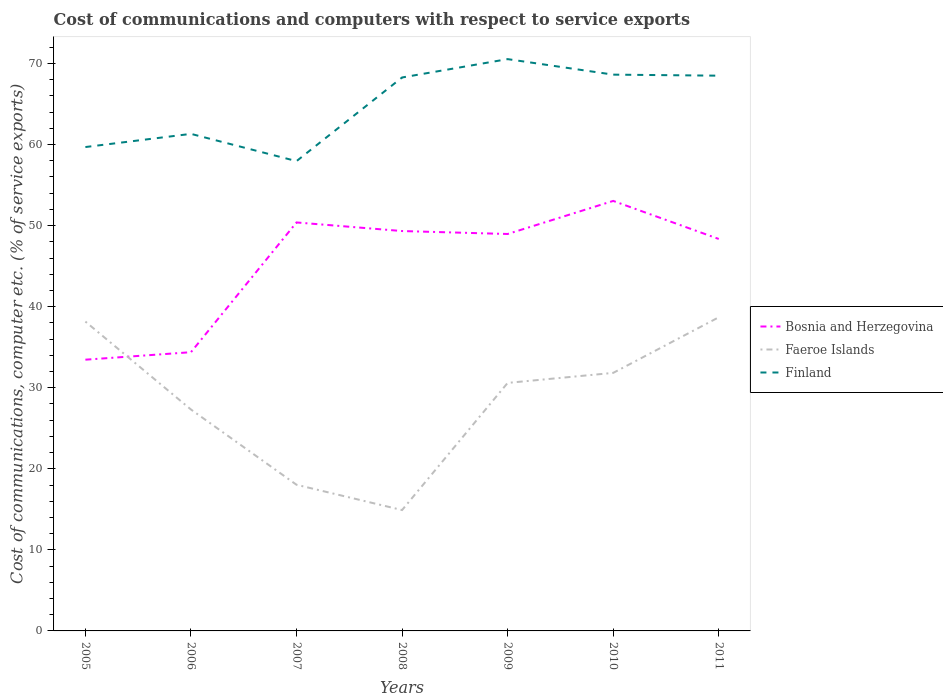Is the number of lines equal to the number of legend labels?
Your answer should be compact. Yes. Across all years, what is the maximum cost of communications and computers in Bosnia and Herzegovina?
Provide a succinct answer. 33.46. In which year was the cost of communications and computers in Finland maximum?
Provide a succinct answer. 2007. What is the total cost of communications and computers in Finland in the graph?
Give a very brief answer. -2.26. What is the difference between the highest and the second highest cost of communications and computers in Bosnia and Herzegovina?
Your answer should be very brief. 19.59. What is the difference between the highest and the lowest cost of communications and computers in Faeroe Islands?
Keep it short and to the point. 4. What is the difference between two consecutive major ticks on the Y-axis?
Make the answer very short. 10. Does the graph contain any zero values?
Make the answer very short. No. Does the graph contain grids?
Give a very brief answer. No. Where does the legend appear in the graph?
Provide a succinct answer. Center right. What is the title of the graph?
Your response must be concise. Cost of communications and computers with respect to service exports. Does "Central African Republic" appear as one of the legend labels in the graph?
Keep it short and to the point. No. What is the label or title of the Y-axis?
Offer a terse response. Cost of communications, computer etc. (% of service exports). What is the Cost of communications, computer etc. (% of service exports) in Bosnia and Herzegovina in 2005?
Keep it short and to the point. 33.46. What is the Cost of communications, computer etc. (% of service exports) in Faeroe Islands in 2005?
Offer a very short reply. 38.16. What is the Cost of communications, computer etc. (% of service exports) of Finland in 2005?
Offer a terse response. 59.69. What is the Cost of communications, computer etc. (% of service exports) in Bosnia and Herzegovina in 2006?
Keep it short and to the point. 34.38. What is the Cost of communications, computer etc. (% of service exports) of Faeroe Islands in 2006?
Give a very brief answer. 27.32. What is the Cost of communications, computer etc. (% of service exports) in Finland in 2006?
Offer a terse response. 61.32. What is the Cost of communications, computer etc. (% of service exports) of Bosnia and Herzegovina in 2007?
Offer a very short reply. 50.39. What is the Cost of communications, computer etc. (% of service exports) of Faeroe Islands in 2007?
Your answer should be compact. 18.03. What is the Cost of communications, computer etc. (% of service exports) of Finland in 2007?
Offer a terse response. 57.95. What is the Cost of communications, computer etc. (% of service exports) in Bosnia and Herzegovina in 2008?
Provide a short and direct response. 49.33. What is the Cost of communications, computer etc. (% of service exports) in Faeroe Islands in 2008?
Your response must be concise. 14.91. What is the Cost of communications, computer etc. (% of service exports) of Finland in 2008?
Make the answer very short. 68.27. What is the Cost of communications, computer etc. (% of service exports) in Bosnia and Herzegovina in 2009?
Give a very brief answer. 48.97. What is the Cost of communications, computer etc. (% of service exports) of Faeroe Islands in 2009?
Keep it short and to the point. 30.6. What is the Cost of communications, computer etc. (% of service exports) of Finland in 2009?
Ensure brevity in your answer.  70.54. What is the Cost of communications, computer etc. (% of service exports) in Bosnia and Herzegovina in 2010?
Give a very brief answer. 53.05. What is the Cost of communications, computer etc. (% of service exports) in Faeroe Islands in 2010?
Offer a very short reply. 31.83. What is the Cost of communications, computer etc. (% of service exports) of Finland in 2010?
Ensure brevity in your answer.  68.62. What is the Cost of communications, computer etc. (% of service exports) in Bosnia and Herzegovina in 2011?
Offer a very short reply. 48.35. What is the Cost of communications, computer etc. (% of service exports) of Faeroe Islands in 2011?
Provide a succinct answer. 38.69. What is the Cost of communications, computer etc. (% of service exports) in Finland in 2011?
Offer a very short reply. 68.5. Across all years, what is the maximum Cost of communications, computer etc. (% of service exports) of Bosnia and Herzegovina?
Offer a terse response. 53.05. Across all years, what is the maximum Cost of communications, computer etc. (% of service exports) in Faeroe Islands?
Provide a succinct answer. 38.69. Across all years, what is the maximum Cost of communications, computer etc. (% of service exports) of Finland?
Keep it short and to the point. 70.54. Across all years, what is the minimum Cost of communications, computer etc. (% of service exports) in Bosnia and Herzegovina?
Your answer should be very brief. 33.46. Across all years, what is the minimum Cost of communications, computer etc. (% of service exports) of Faeroe Islands?
Make the answer very short. 14.91. Across all years, what is the minimum Cost of communications, computer etc. (% of service exports) in Finland?
Your response must be concise. 57.95. What is the total Cost of communications, computer etc. (% of service exports) of Bosnia and Herzegovina in the graph?
Your response must be concise. 317.93. What is the total Cost of communications, computer etc. (% of service exports) of Faeroe Islands in the graph?
Provide a succinct answer. 199.54. What is the total Cost of communications, computer etc. (% of service exports) of Finland in the graph?
Provide a short and direct response. 454.9. What is the difference between the Cost of communications, computer etc. (% of service exports) of Bosnia and Herzegovina in 2005 and that in 2006?
Provide a succinct answer. -0.92. What is the difference between the Cost of communications, computer etc. (% of service exports) in Faeroe Islands in 2005 and that in 2006?
Your answer should be very brief. 10.85. What is the difference between the Cost of communications, computer etc. (% of service exports) in Finland in 2005 and that in 2006?
Make the answer very short. -1.63. What is the difference between the Cost of communications, computer etc. (% of service exports) of Bosnia and Herzegovina in 2005 and that in 2007?
Your answer should be very brief. -16.93. What is the difference between the Cost of communications, computer etc. (% of service exports) in Faeroe Islands in 2005 and that in 2007?
Ensure brevity in your answer.  20.13. What is the difference between the Cost of communications, computer etc. (% of service exports) of Finland in 2005 and that in 2007?
Ensure brevity in your answer.  1.74. What is the difference between the Cost of communications, computer etc. (% of service exports) in Bosnia and Herzegovina in 2005 and that in 2008?
Your answer should be very brief. -15.87. What is the difference between the Cost of communications, computer etc. (% of service exports) of Faeroe Islands in 2005 and that in 2008?
Your answer should be compact. 23.25. What is the difference between the Cost of communications, computer etc. (% of service exports) in Finland in 2005 and that in 2008?
Your answer should be compact. -8.58. What is the difference between the Cost of communications, computer etc. (% of service exports) of Bosnia and Herzegovina in 2005 and that in 2009?
Give a very brief answer. -15.51. What is the difference between the Cost of communications, computer etc. (% of service exports) in Faeroe Islands in 2005 and that in 2009?
Offer a terse response. 7.56. What is the difference between the Cost of communications, computer etc. (% of service exports) of Finland in 2005 and that in 2009?
Provide a short and direct response. -10.85. What is the difference between the Cost of communications, computer etc. (% of service exports) of Bosnia and Herzegovina in 2005 and that in 2010?
Offer a terse response. -19.59. What is the difference between the Cost of communications, computer etc. (% of service exports) in Faeroe Islands in 2005 and that in 2010?
Provide a short and direct response. 6.33. What is the difference between the Cost of communications, computer etc. (% of service exports) of Finland in 2005 and that in 2010?
Ensure brevity in your answer.  -8.93. What is the difference between the Cost of communications, computer etc. (% of service exports) of Bosnia and Herzegovina in 2005 and that in 2011?
Offer a very short reply. -14.89. What is the difference between the Cost of communications, computer etc. (% of service exports) of Faeroe Islands in 2005 and that in 2011?
Your answer should be compact. -0.53. What is the difference between the Cost of communications, computer etc. (% of service exports) in Finland in 2005 and that in 2011?
Provide a short and direct response. -8.8. What is the difference between the Cost of communications, computer etc. (% of service exports) of Bosnia and Herzegovina in 2006 and that in 2007?
Give a very brief answer. -16.01. What is the difference between the Cost of communications, computer etc. (% of service exports) in Faeroe Islands in 2006 and that in 2007?
Offer a terse response. 9.28. What is the difference between the Cost of communications, computer etc. (% of service exports) of Finland in 2006 and that in 2007?
Your answer should be compact. 3.36. What is the difference between the Cost of communications, computer etc. (% of service exports) of Bosnia and Herzegovina in 2006 and that in 2008?
Your answer should be very brief. -14.95. What is the difference between the Cost of communications, computer etc. (% of service exports) in Faeroe Islands in 2006 and that in 2008?
Offer a terse response. 12.41. What is the difference between the Cost of communications, computer etc. (% of service exports) of Finland in 2006 and that in 2008?
Ensure brevity in your answer.  -6.96. What is the difference between the Cost of communications, computer etc. (% of service exports) of Bosnia and Herzegovina in 2006 and that in 2009?
Offer a terse response. -14.58. What is the difference between the Cost of communications, computer etc. (% of service exports) of Faeroe Islands in 2006 and that in 2009?
Your answer should be very brief. -3.28. What is the difference between the Cost of communications, computer etc. (% of service exports) in Finland in 2006 and that in 2009?
Give a very brief answer. -9.22. What is the difference between the Cost of communications, computer etc. (% of service exports) in Bosnia and Herzegovina in 2006 and that in 2010?
Give a very brief answer. -18.66. What is the difference between the Cost of communications, computer etc. (% of service exports) of Faeroe Islands in 2006 and that in 2010?
Your response must be concise. -4.52. What is the difference between the Cost of communications, computer etc. (% of service exports) in Finland in 2006 and that in 2010?
Offer a terse response. -7.31. What is the difference between the Cost of communications, computer etc. (% of service exports) in Bosnia and Herzegovina in 2006 and that in 2011?
Your answer should be very brief. -13.97. What is the difference between the Cost of communications, computer etc. (% of service exports) of Faeroe Islands in 2006 and that in 2011?
Provide a succinct answer. -11.38. What is the difference between the Cost of communications, computer etc. (% of service exports) in Finland in 2006 and that in 2011?
Make the answer very short. -7.18. What is the difference between the Cost of communications, computer etc. (% of service exports) in Bosnia and Herzegovina in 2007 and that in 2008?
Give a very brief answer. 1.06. What is the difference between the Cost of communications, computer etc. (% of service exports) of Faeroe Islands in 2007 and that in 2008?
Ensure brevity in your answer.  3.12. What is the difference between the Cost of communications, computer etc. (% of service exports) in Finland in 2007 and that in 2008?
Offer a very short reply. -10.32. What is the difference between the Cost of communications, computer etc. (% of service exports) of Bosnia and Herzegovina in 2007 and that in 2009?
Your answer should be compact. 1.42. What is the difference between the Cost of communications, computer etc. (% of service exports) of Faeroe Islands in 2007 and that in 2009?
Make the answer very short. -12.57. What is the difference between the Cost of communications, computer etc. (% of service exports) of Finland in 2007 and that in 2009?
Your answer should be compact. -12.58. What is the difference between the Cost of communications, computer etc. (% of service exports) of Bosnia and Herzegovina in 2007 and that in 2010?
Make the answer very short. -2.66. What is the difference between the Cost of communications, computer etc. (% of service exports) in Faeroe Islands in 2007 and that in 2010?
Ensure brevity in your answer.  -13.8. What is the difference between the Cost of communications, computer etc. (% of service exports) in Finland in 2007 and that in 2010?
Your answer should be very brief. -10.67. What is the difference between the Cost of communications, computer etc. (% of service exports) of Bosnia and Herzegovina in 2007 and that in 2011?
Offer a very short reply. 2.04. What is the difference between the Cost of communications, computer etc. (% of service exports) of Faeroe Islands in 2007 and that in 2011?
Keep it short and to the point. -20.66. What is the difference between the Cost of communications, computer etc. (% of service exports) of Finland in 2007 and that in 2011?
Provide a short and direct response. -10.54. What is the difference between the Cost of communications, computer etc. (% of service exports) in Bosnia and Herzegovina in 2008 and that in 2009?
Ensure brevity in your answer.  0.36. What is the difference between the Cost of communications, computer etc. (% of service exports) in Faeroe Islands in 2008 and that in 2009?
Offer a terse response. -15.69. What is the difference between the Cost of communications, computer etc. (% of service exports) of Finland in 2008 and that in 2009?
Offer a terse response. -2.26. What is the difference between the Cost of communications, computer etc. (% of service exports) of Bosnia and Herzegovina in 2008 and that in 2010?
Provide a succinct answer. -3.72. What is the difference between the Cost of communications, computer etc. (% of service exports) in Faeroe Islands in 2008 and that in 2010?
Your answer should be compact. -16.92. What is the difference between the Cost of communications, computer etc. (% of service exports) in Finland in 2008 and that in 2010?
Give a very brief answer. -0.35. What is the difference between the Cost of communications, computer etc. (% of service exports) of Bosnia and Herzegovina in 2008 and that in 2011?
Your answer should be compact. 0.98. What is the difference between the Cost of communications, computer etc. (% of service exports) of Faeroe Islands in 2008 and that in 2011?
Your response must be concise. -23.78. What is the difference between the Cost of communications, computer etc. (% of service exports) of Finland in 2008 and that in 2011?
Give a very brief answer. -0.22. What is the difference between the Cost of communications, computer etc. (% of service exports) of Bosnia and Herzegovina in 2009 and that in 2010?
Provide a short and direct response. -4.08. What is the difference between the Cost of communications, computer etc. (% of service exports) of Faeroe Islands in 2009 and that in 2010?
Keep it short and to the point. -1.24. What is the difference between the Cost of communications, computer etc. (% of service exports) in Finland in 2009 and that in 2010?
Keep it short and to the point. 1.91. What is the difference between the Cost of communications, computer etc. (% of service exports) of Bosnia and Herzegovina in 2009 and that in 2011?
Offer a very short reply. 0.61. What is the difference between the Cost of communications, computer etc. (% of service exports) of Faeroe Islands in 2009 and that in 2011?
Your response must be concise. -8.1. What is the difference between the Cost of communications, computer etc. (% of service exports) in Finland in 2009 and that in 2011?
Your answer should be compact. 2.04. What is the difference between the Cost of communications, computer etc. (% of service exports) in Bosnia and Herzegovina in 2010 and that in 2011?
Keep it short and to the point. 4.69. What is the difference between the Cost of communications, computer etc. (% of service exports) in Faeroe Islands in 2010 and that in 2011?
Make the answer very short. -6.86. What is the difference between the Cost of communications, computer etc. (% of service exports) of Finland in 2010 and that in 2011?
Offer a very short reply. 0.13. What is the difference between the Cost of communications, computer etc. (% of service exports) of Bosnia and Herzegovina in 2005 and the Cost of communications, computer etc. (% of service exports) of Faeroe Islands in 2006?
Keep it short and to the point. 6.14. What is the difference between the Cost of communications, computer etc. (% of service exports) of Bosnia and Herzegovina in 2005 and the Cost of communications, computer etc. (% of service exports) of Finland in 2006?
Provide a succinct answer. -27.86. What is the difference between the Cost of communications, computer etc. (% of service exports) of Faeroe Islands in 2005 and the Cost of communications, computer etc. (% of service exports) of Finland in 2006?
Provide a succinct answer. -23.16. What is the difference between the Cost of communications, computer etc. (% of service exports) of Bosnia and Herzegovina in 2005 and the Cost of communications, computer etc. (% of service exports) of Faeroe Islands in 2007?
Your answer should be compact. 15.43. What is the difference between the Cost of communications, computer etc. (% of service exports) of Bosnia and Herzegovina in 2005 and the Cost of communications, computer etc. (% of service exports) of Finland in 2007?
Your answer should be very brief. -24.5. What is the difference between the Cost of communications, computer etc. (% of service exports) in Faeroe Islands in 2005 and the Cost of communications, computer etc. (% of service exports) in Finland in 2007?
Offer a very short reply. -19.79. What is the difference between the Cost of communications, computer etc. (% of service exports) in Bosnia and Herzegovina in 2005 and the Cost of communications, computer etc. (% of service exports) in Faeroe Islands in 2008?
Keep it short and to the point. 18.55. What is the difference between the Cost of communications, computer etc. (% of service exports) of Bosnia and Herzegovina in 2005 and the Cost of communications, computer etc. (% of service exports) of Finland in 2008?
Provide a succinct answer. -34.81. What is the difference between the Cost of communications, computer etc. (% of service exports) of Faeroe Islands in 2005 and the Cost of communications, computer etc. (% of service exports) of Finland in 2008?
Make the answer very short. -30.11. What is the difference between the Cost of communications, computer etc. (% of service exports) in Bosnia and Herzegovina in 2005 and the Cost of communications, computer etc. (% of service exports) in Faeroe Islands in 2009?
Ensure brevity in your answer.  2.86. What is the difference between the Cost of communications, computer etc. (% of service exports) of Bosnia and Herzegovina in 2005 and the Cost of communications, computer etc. (% of service exports) of Finland in 2009?
Give a very brief answer. -37.08. What is the difference between the Cost of communications, computer etc. (% of service exports) of Faeroe Islands in 2005 and the Cost of communications, computer etc. (% of service exports) of Finland in 2009?
Ensure brevity in your answer.  -32.38. What is the difference between the Cost of communications, computer etc. (% of service exports) of Bosnia and Herzegovina in 2005 and the Cost of communications, computer etc. (% of service exports) of Faeroe Islands in 2010?
Provide a succinct answer. 1.63. What is the difference between the Cost of communications, computer etc. (% of service exports) in Bosnia and Herzegovina in 2005 and the Cost of communications, computer etc. (% of service exports) in Finland in 2010?
Provide a short and direct response. -35.16. What is the difference between the Cost of communications, computer etc. (% of service exports) of Faeroe Islands in 2005 and the Cost of communications, computer etc. (% of service exports) of Finland in 2010?
Your answer should be very brief. -30.46. What is the difference between the Cost of communications, computer etc. (% of service exports) of Bosnia and Herzegovina in 2005 and the Cost of communications, computer etc. (% of service exports) of Faeroe Islands in 2011?
Your answer should be very brief. -5.23. What is the difference between the Cost of communications, computer etc. (% of service exports) in Bosnia and Herzegovina in 2005 and the Cost of communications, computer etc. (% of service exports) in Finland in 2011?
Your answer should be very brief. -35.04. What is the difference between the Cost of communications, computer etc. (% of service exports) in Faeroe Islands in 2005 and the Cost of communications, computer etc. (% of service exports) in Finland in 2011?
Provide a succinct answer. -30.33. What is the difference between the Cost of communications, computer etc. (% of service exports) in Bosnia and Herzegovina in 2006 and the Cost of communications, computer etc. (% of service exports) in Faeroe Islands in 2007?
Your answer should be compact. 16.35. What is the difference between the Cost of communications, computer etc. (% of service exports) in Bosnia and Herzegovina in 2006 and the Cost of communications, computer etc. (% of service exports) in Finland in 2007?
Your response must be concise. -23.57. What is the difference between the Cost of communications, computer etc. (% of service exports) of Faeroe Islands in 2006 and the Cost of communications, computer etc. (% of service exports) of Finland in 2007?
Provide a short and direct response. -30.64. What is the difference between the Cost of communications, computer etc. (% of service exports) of Bosnia and Herzegovina in 2006 and the Cost of communications, computer etc. (% of service exports) of Faeroe Islands in 2008?
Offer a terse response. 19.47. What is the difference between the Cost of communications, computer etc. (% of service exports) of Bosnia and Herzegovina in 2006 and the Cost of communications, computer etc. (% of service exports) of Finland in 2008?
Provide a short and direct response. -33.89. What is the difference between the Cost of communications, computer etc. (% of service exports) of Faeroe Islands in 2006 and the Cost of communications, computer etc. (% of service exports) of Finland in 2008?
Offer a terse response. -40.96. What is the difference between the Cost of communications, computer etc. (% of service exports) of Bosnia and Herzegovina in 2006 and the Cost of communications, computer etc. (% of service exports) of Faeroe Islands in 2009?
Offer a terse response. 3.79. What is the difference between the Cost of communications, computer etc. (% of service exports) of Bosnia and Herzegovina in 2006 and the Cost of communications, computer etc. (% of service exports) of Finland in 2009?
Provide a short and direct response. -36.15. What is the difference between the Cost of communications, computer etc. (% of service exports) in Faeroe Islands in 2006 and the Cost of communications, computer etc. (% of service exports) in Finland in 2009?
Give a very brief answer. -43.22. What is the difference between the Cost of communications, computer etc. (% of service exports) of Bosnia and Herzegovina in 2006 and the Cost of communications, computer etc. (% of service exports) of Faeroe Islands in 2010?
Keep it short and to the point. 2.55. What is the difference between the Cost of communications, computer etc. (% of service exports) of Bosnia and Herzegovina in 2006 and the Cost of communications, computer etc. (% of service exports) of Finland in 2010?
Your answer should be compact. -34.24. What is the difference between the Cost of communications, computer etc. (% of service exports) in Faeroe Islands in 2006 and the Cost of communications, computer etc. (% of service exports) in Finland in 2010?
Provide a succinct answer. -41.31. What is the difference between the Cost of communications, computer etc. (% of service exports) of Bosnia and Herzegovina in 2006 and the Cost of communications, computer etc. (% of service exports) of Faeroe Islands in 2011?
Offer a very short reply. -4.31. What is the difference between the Cost of communications, computer etc. (% of service exports) of Bosnia and Herzegovina in 2006 and the Cost of communications, computer etc. (% of service exports) of Finland in 2011?
Your response must be concise. -34.11. What is the difference between the Cost of communications, computer etc. (% of service exports) of Faeroe Islands in 2006 and the Cost of communications, computer etc. (% of service exports) of Finland in 2011?
Keep it short and to the point. -41.18. What is the difference between the Cost of communications, computer etc. (% of service exports) in Bosnia and Herzegovina in 2007 and the Cost of communications, computer etc. (% of service exports) in Faeroe Islands in 2008?
Give a very brief answer. 35.48. What is the difference between the Cost of communications, computer etc. (% of service exports) in Bosnia and Herzegovina in 2007 and the Cost of communications, computer etc. (% of service exports) in Finland in 2008?
Ensure brevity in your answer.  -17.88. What is the difference between the Cost of communications, computer etc. (% of service exports) of Faeroe Islands in 2007 and the Cost of communications, computer etc. (% of service exports) of Finland in 2008?
Provide a succinct answer. -50.24. What is the difference between the Cost of communications, computer etc. (% of service exports) in Bosnia and Herzegovina in 2007 and the Cost of communications, computer etc. (% of service exports) in Faeroe Islands in 2009?
Provide a short and direct response. 19.79. What is the difference between the Cost of communications, computer etc. (% of service exports) of Bosnia and Herzegovina in 2007 and the Cost of communications, computer etc. (% of service exports) of Finland in 2009?
Offer a terse response. -20.15. What is the difference between the Cost of communications, computer etc. (% of service exports) in Faeroe Islands in 2007 and the Cost of communications, computer etc. (% of service exports) in Finland in 2009?
Offer a terse response. -52.51. What is the difference between the Cost of communications, computer etc. (% of service exports) in Bosnia and Herzegovina in 2007 and the Cost of communications, computer etc. (% of service exports) in Faeroe Islands in 2010?
Give a very brief answer. 18.56. What is the difference between the Cost of communications, computer etc. (% of service exports) of Bosnia and Herzegovina in 2007 and the Cost of communications, computer etc. (% of service exports) of Finland in 2010?
Your answer should be very brief. -18.23. What is the difference between the Cost of communications, computer etc. (% of service exports) in Faeroe Islands in 2007 and the Cost of communications, computer etc. (% of service exports) in Finland in 2010?
Make the answer very short. -50.59. What is the difference between the Cost of communications, computer etc. (% of service exports) in Bosnia and Herzegovina in 2007 and the Cost of communications, computer etc. (% of service exports) in Faeroe Islands in 2011?
Offer a very short reply. 11.7. What is the difference between the Cost of communications, computer etc. (% of service exports) of Bosnia and Herzegovina in 2007 and the Cost of communications, computer etc. (% of service exports) of Finland in 2011?
Make the answer very short. -18.11. What is the difference between the Cost of communications, computer etc. (% of service exports) in Faeroe Islands in 2007 and the Cost of communications, computer etc. (% of service exports) in Finland in 2011?
Your response must be concise. -50.47. What is the difference between the Cost of communications, computer etc. (% of service exports) in Bosnia and Herzegovina in 2008 and the Cost of communications, computer etc. (% of service exports) in Faeroe Islands in 2009?
Provide a succinct answer. 18.73. What is the difference between the Cost of communications, computer etc. (% of service exports) of Bosnia and Herzegovina in 2008 and the Cost of communications, computer etc. (% of service exports) of Finland in 2009?
Your answer should be very brief. -21.21. What is the difference between the Cost of communications, computer etc. (% of service exports) in Faeroe Islands in 2008 and the Cost of communications, computer etc. (% of service exports) in Finland in 2009?
Provide a succinct answer. -55.63. What is the difference between the Cost of communications, computer etc. (% of service exports) in Bosnia and Herzegovina in 2008 and the Cost of communications, computer etc. (% of service exports) in Faeroe Islands in 2010?
Make the answer very short. 17.5. What is the difference between the Cost of communications, computer etc. (% of service exports) in Bosnia and Herzegovina in 2008 and the Cost of communications, computer etc. (% of service exports) in Finland in 2010?
Ensure brevity in your answer.  -19.29. What is the difference between the Cost of communications, computer etc. (% of service exports) in Faeroe Islands in 2008 and the Cost of communications, computer etc. (% of service exports) in Finland in 2010?
Make the answer very short. -53.71. What is the difference between the Cost of communications, computer etc. (% of service exports) in Bosnia and Herzegovina in 2008 and the Cost of communications, computer etc. (% of service exports) in Faeroe Islands in 2011?
Your response must be concise. 10.64. What is the difference between the Cost of communications, computer etc. (% of service exports) of Bosnia and Herzegovina in 2008 and the Cost of communications, computer etc. (% of service exports) of Finland in 2011?
Offer a very short reply. -19.17. What is the difference between the Cost of communications, computer etc. (% of service exports) in Faeroe Islands in 2008 and the Cost of communications, computer etc. (% of service exports) in Finland in 2011?
Offer a very short reply. -53.59. What is the difference between the Cost of communications, computer etc. (% of service exports) of Bosnia and Herzegovina in 2009 and the Cost of communications, computer etc. (% of service exports) of Faeroe Islands in 2010?
Offer a very short reply. 17.13. What is the difference between the Cost of communications, computer etc. (% of service exports) in Bosnia and Herzegovina in 2009 and the Cost of communications, computer etc. (% of service exports) in Finland in 2010?
Provide a succinct answer. -19.66. What is the difference between the Cost of communications, computer etc. (% of service exports) in Faeroe Islands in 2009 and the Cost of communications, computer etc. (% of service exports) in Finland in 2010?
Keep it short and to the point. -38.03. What is the difference between the Cost of communications, computer etc. (% of service exports) of Bosnia and Herzegovina in 2009 and the Cost of communications, computer etc. (% of service exports) of Faeroe Islands in 2011?
Your answer should be very brief. 10.27. What is the difference between the Cost of communications, computer etc. (% of service exports) in Bosnia and Herzegovina in 2009 and the Cost of communications, computer etc. (% of service exports) in Finland in 2011?
Your answer should be compact. -19.53. What is the difference between the Cost of communications, computer etc. (% of service exports) of Faeroe Islands in 2009 and the Cost of communications, computer etc. (% of service exports) of Finland in 2011?
Ensure brevity in your answer.  -37.9. What is the difference between the Cost of communications, computer etc. (% of service exports) of Bosnia and Herzegovina in 2010 and the Cost of communications, computer etc. (% of service exports) of Faeroe Islands in 2011?
Provide a succinct answer. 14.35. What is the difference between the Cost of communications, computer etc. (% of service exports) of Bosnia and Herzegovina in 2010 and the Cost of communications, computer etc. (% of service exports) of Finland in 2011?
Provide a short and direct response. -15.45. What is the difference between the Cost of communications, computer etc. (% of service exports) of Faeroe Islands in 2010 and the Cost of communications, computer etc. (% of service exports) of Finland in 2011?
Give a very brief answer. -36.66. What is the average Cost of communications, computer etc. (% of service exports) in Bosnia and Herzegovina per year?
Ensure brevity in your answer.  45.42. What is the average Cost of communications, computer etc. (% of service exports) of Faeroe Islands per year?
Your response must be concise. 28.51. What is the average Cost of communications, computer etc. (% of service exports) of Finland per year?
Your answer should be very brief. 64.99. In the year 2005, what is the difference between the Cost of communications, computer etc. (% of service exports) in Bosnia and Herzegovina and Cost of communications, computer etc. (% of service exports) in Faeroe Islands?
Provide a short and direct response. -4.7. In the year 2005, what is the difference between the Cost of communications, computer etc. (% of service exports) of Bosnia and Herzegovina and Cost of communications, computer etc. (% of service exports) of Finland?
Your answer should be compact. -26.23. In the year 2005, what is the difference between the Cost of communications, computer etc. (% of service exports) of Faeroe Islands and Cost of communications, computer etc. (% of service exports) of Finland?
Give a very brief answer. -21.53. In the year 2006, what is the difference between the Cost of communications, computer etc. (% of service exports) of Bosnia and Herzegovina and Cost of communications, computer etc. (% of service exports) of Faeroe Islands?
Ensure brevity in your answer.  7.07. In the year 2006, what is the difference between the Cost of communications, computer etc. (% of service exports) in Bosnia and Herzegovina and Cost of communications, computer etc. (% of service exports) in Finland?
Give a very brief answer. -26.93. In the year 2006, what is the difference between the Cost of communications, computer etc. (% of service exports) in Faeroe Islands and Cost of communications, computer etc. (% of service exports) in Finland?
Ensure brevity in your answer.  -34. In the year 2007, what is the difference between the Cost of communications, computer etc. (% of service exports) in Bosnia and Herzegovina and Cost of communications, computer etc. (% of service exports) in Faeroe Islands?
Offer a very short reply. 32.36. In the year 2007, what is the difference between the Cost of communications, computer etc. (% of service exports) of Bosnia and Herzegovina and Cost of communications, computer etc. (% of service exports) of Finland?
Your answer should be compact. -7.56. In the year 2007, what is the difference between the Cost of communications, computer etc. (% of service exports) in Faeroe Islands and Cost of communications, computer etc. (% of service exports) in Finland?
Provide a succinct answer. -39.92. In the year 2008, what is the difference between the Cost of communications, computer etc. (% of service exports) in Bosnia and Herzegovina and Cost of communications, computer etc. (% of service exports) in Faeroe Islands?
Ensure brevity in your answer.  34.42. In the year 2008, what is the difference between the Cost of communications, computer etc. (% of service exports) in Bosnia and Herzegovina and Cost of communications, computer etc. (% of service exports) in Finland?
Your answer should be very brief. -18.94. In the year 2008, what is the difference between the Cost of communications, computer etc. (% of service exports) of Faeroe Islands and Cost of communications, computer etc. (% of service exports) of Finland?
Ensure brevity in your answer.  -53.36. In the year 2009, what is the difference between the Cost of communications, computer etc. (% of service exports) in Bosnia and Herzegovina and Cost of communications, computer etc. (% of service exports) in Faeroe Islands?
Give a very brief answer. 18.37. In the year 2009, what is the difference between the Cost of communications, computer etc. (% of service exports) in Bosnia and Herzegovina and Cost of communications, computer etc. (% of service exports) in Finland?
Offer a terse response. -21.57. In the year 2009, what is the difference between the Cost of communications, computer etc. (% of service exports) in Faeroe Islands and Cost of communications, computer etc. (% of service exports) in Finland?
Keep it short and to the point. -39.94. In the year 2010, what is the difference between the Cost of communications, computer etc. (% of service exports) in Bosnia and Herzegovina and Cost of communications, computer etc. (% of service exports) in Faeroe Islands?
Offer a very short reply. 21.21. In the year 2010, what is the difference between the Cost of communications, computer etc. (% of service exports) in Bosnia and Herzegovina and Cost of communications, computer etc. (% of service exports) in Finland?
Give a very brief answer. -15.58. In the year 2010, what is the difference between the Cost of communications, computer etc. (% of service exports) in Faeroe Islands and Cost of communications, computer etc. (% of service exports) in Finland?
Provide a short and direct response. -36.79. In the year 2011, what is the difference between the Cost of communications, computer etc. (% of service exports) of Bosnia and Herzegovina and Cost of communications, computer etc. (% of service exports) of Faeroe Islands?
Offer a terse response. 9.66. In the year 2011, what is the difference between the Cost of communications, computer etc. (% of service exports) of Bosnia and Herzegovina and Cost of communications, computer etc. (% of service exports) of Finland?
Give a very brief answer. -20.14. In the year 2011, what is the difference between the Cost of communications, computer etc. (% of service exports) of Faeroe Islands and Cost of communications, computer etc. (% of service exports) of Finland?
Provide a succinct answer. -29.8. What is the ratio of the Cost of communications, computer etc. (% of service exports) in Bosnia and Herzegovina in 2005 to that in 2006?
Your answer should be compact. 0.97. What is the ratio of the Cost of communications, computer etc. (% of service exports) in Faeroe Islands in 2005 to that in 2006?
Provide a short and direct response. 1.4. What is the ratio of the Cost of communications, computer etc. (% of service exports) in Finland in 2005 to that in 2006?
Offer a terse response. 0.97. What is the ratio of the Cost of communications, computer etc. (% of service exports) of Bosnia and Herzegovina in 2005 to that in 2007?
Your response must be concise. 0.66. What is the ratio of the Cost of communications, computer etc. (% of service exports) of Faeroe Islands in 2005 to that in 2007?
Offer a very short reply. 2.12. What is the ratio of the Cost of communications, computer etc. (% of service exports) in Finland in 2005 to that in 2007?
Offer a very short reply. 1.03. What is the ratio of the Cost of communications, computer etc. (% of service exports) in Bosnia and Herzegovina in 2005 to that in 2008?
Offer a terse response. 0.68. What is the ratio of the Cost of communications, computer etc. (% of service exports) of Faeroe Islands in 2005 to that in 2008?
Keep it short and to the point. 2.56. What is the ratio of the Cost of communications, computer etc. (% of service exports) of Finland in 2005 to that in 2008?
Your answer should be very brief. 0.87. What is the ratio of the Cost of communications, computer etc. (% of service exports) in Bosnia and Herzegovina in 2005 to that in 2009?
Provide a short and direct response. 0.68. What is the ratio of the Cost of communications, computer etc. (% of service exports) of Faeroe Islands in 2005 to that in 2009?
Your answer should be compact. 1.25. What is the ratio of the Cost of communications, computer etc. (% of service exports) of Finland in 2005 to that in 2009?
Provide a succinct answer. 0.85. What is the ratio of the Cost of communications, computer etc. (% of service exports) of Bosnia and Herzegovina in 2005 to that in 2010?
Provide a short and direct response. 0.63. What is the ratio of the Cost of communications, computer etc. (% of service exports) in Faeroe Islands in 2005 to that in 2010?
Provide a short and direct response. 1.2. What is the ratio of the Cost of communications, computer etc. (% of service exports) of Finland in 2005 to that in 2010?
Keep it short and to the point. 0.87. What is the ratio of the Cost of communications, computer etc. (% of service exports) of Bosnia and Herzegovina in 2005 to that in 2011?
Offer a terse response. 0.69. What is the ratio of the Cost of communications, computer etc. (% of service exports) in Faeroe Islands in 2005 to that in 2011?
Provide a short and direct response. 0.99. What is the ratio of the Cost of communications, computer etc. (% of service exports) in Finland in 2005 to that in 2011?
Your answer should be very brief. 0.87. What is the ratio of the Cost of communications, computer etc. (% of service exports) of Bosnia and Herzegovina in 2006 to that in 2007?
Your answer should be compact. 0.68. What is the ratio of the Cost of communications, computer etc. (% of service exports) of Faeroe Islands in 2006 to that in 2007?
Offer a terse response. 1.51. What is the ratio of the Cost of communications, computer etc. (% of service exports) in Finland in 2006 to that in 2007?
Provide a succinct answer. 1.06. What is the ratio of the Cost of communications, computer etc. (% of service exports) in Bosnia and Herzegovina in 2006 to that in 2008?
Your answer should be compact. 0.7. What is the ratio of the Cost of communications, computer etc. (% of service exports) in Faeroe Islands in 2006 to that in 2008?
Offer a terse response. 1.83. What is the ratio of the Cost of communications, computer etc. (% of service exports) of Finland in 2006 to that in 2008?
Your response must be concise. 0.9. What is the ratio of the Cost of communications, computer etc. (% of service exports) of Bosnia and Herzegovina in 2006 to that in 2009?
Ensure brevity in your answer.  0.7. What is the ratio of the Cost of communications, computer etc. (% of service exports) of Faeroe Islands in 2006 to that in 2009?
Offer a very short reply. 0.89. What is the ratio of the Cost of communications, computer etc. (% of service exports) in Finland in 2006 to that in 2009?
Your answer should be very brief. 0.87. What is the ratio of the Cost of communications, computer etc. (% of service exports) of Bosnia and Herzegovina in 2006 to that in 2010?
Give a very brief answer. 0.65. What is the ratio of the Cost of communications, computer etc. (% of service exports) in Faeroe Islands in 2006 to that in 2010?
Your answer should be compact. 0.86. What is the ratio of the Cost of communications, computer etc. (% of service exports) of Finland in 2006 to that in 2010?
Provide a short and direct response. 0.89. What is the ratio of the Cost of communications, computer etc. (% of service exports) of Bosnia and Herzegovina in 2006 to that in 2011?
Provide a short and direct response. 0.71. What is the ratio of the Cost of communications, computer etc. (% of service exports) in Faeroe Islands in 2006 to that in 2011?
Keep it short and to the point. 0.71. What is the ratio of the Cost of communications, computer etc. (% of service exports) in Finland in 2006 to that in 2011?
Provide a succinct answer. 0.9. What is the ratio of the Cost of communications, computer etc. (% of service exports) of Bosnia and Herzegovina in 2007 to that in 2008?
Your answer should be compact. 1.02. What is the ratio of the Cost of communications, computer etc. (% of service exports) in Faeroe Islands in 2007 to that in 2008?
Make the answer very short. 1.21. What is the ratio of the Cost of communications, computer etc. (% of service exports) of Finland in 2007 to that in 2008?
Offer a very short reply. 0.85. What is the ratio of the Cost of communications, computer etc. (% of service exports) of Bosnia and Herzegovina in 2007 to that in 2009?
Provide a short and direct response. 1.03. What is the ratio of the Cost of communications, computer etc. (% of service exports) in Faeroe Islands in 2007 to that in 2009?
Make the answer very short. 0.59. What is the ratio of the Cost of communications, computer etc. (% of service exports) in Finland in 2007 to that in 2009?
Provide a succinct answer. 0.82. What is the ratio of the Cost of communications, computer etc. (% of service exports) in Bosnia and Herzegovina in 2007 to that in 2010?
Offer a very short reply. 0.95. What is the ratio of the Cost of communications, computer etc. (% of service exports) in Faeroe Islands in 2007 to that in 2010?
Provide a short and direct response. 0.57. What is the ratio of the Cost of communications, computer etc. (% of service exports) of Finland in 2007 to that in 2010?
Your answer should be very brief. 0.84. What is the ratio of the Cost of communications, computer etc. (% of service exports) in Bosnia and Herzegovina in 2007 to that in 2011?
Provide a succinct answer. 1.04. What is the ratio of the Cost of communications, computer etc. (% of service exports) in Faeroe Islands in 2007 to that in 2011?
Offer a terse response. 0.47. What is the ratio of the Cost of communications, computer etc. (% of service exports) in Finland in 2007 to that in 2011?
Your answer should be very brief. 0.85. What is the ratio of the Cost of communications, computer etc. (% of service exports) of Bosnia and Herzegovina in 2008 to that in 2009?
Keep it short and to the point. 1.01. What is the ratio of the Cost of communications, computer etc. (% of service exports) of Faeroe Islands in 2008 to that in 2009?
Your answer should be compact. 0.49. What is the ratio of the Cost of communications, computer etc. (% of service exports) of Finland in 2008 to that in 2009?
Offer a terse response. 0.97. What is the ratio of the Cost of communications, computer etc. (% of service exports) in Bosnia and Herzegovina in 2008 to that in 2010?
Your response must be concise. 0.93. What is the ratio of the Cost of communications, computer etc. (% of service exports) of Faeroe Islands in 2008 to that in 2010?
Make the answer very short. 0.47. What is the ratio of the Cost of communications, computer etc. (% of service exports) of Bosnia and Herzegovina in 2008 to that in 2011?
Provide a succinct answer. 1.02. What is the ratio of the Cost of communications, computer etc. (% of service exports) of Faeroe Islands in 2008 to that in 2011?
Your answer should be very brief. 0.39. What is the ratio of the Cost of communications, computer etc. (% of service exports) of Faeroe Islands in 2009 to that in 2010?
Your response must be concise. 0.96. What is the ratio of the Cost of communications, computer etc. (% of service exports) of Finland in 2009 to that in 2010?
Your answer should be very brief. 1.03. What is the ratio of the Cost of communications, computer etc. (% of service exports) in Bosnia and Herzegovina in 2009 to that in 2011?
Your answer should be very brief. 1.01. What is the ratio of the Cost of communications, computer etc. (% of service exports) in Faeroe Islands in 2009 to that in 2011?
Your response must be concise. 0.79. What is the ratio of the Cost of communications, computer etc. (% of service exports) in Finland in 2009 to that in 2011?
Your answer should be very brief. 1.03. What is the ratio of the Cost of communications, computer etc. (% of service exports) in Bosnia and Herzegovina in 2010 to that in 2011?
Provide a short and direct response. 1.1. What is the ratio of the Cost of communications, computer etc. (% of service exports) in Faeroe Islands in 2010 to that in 2011?
Provide a succinct answer. 0.82. What is the ratio of the Cost of communications, computer etc. (% of service exports) in Finland in 2010 to that in 2011?
Provide a short and direct response. 1. What is the difference between the highest and the second highest Cost of communications, computer etc. (% of service exports) of Bosnia and Herzegovina?
Keep it short and to the point. 2.66. What is the difference between the highest and the second highest Cost of communications, computer etc. (% of service exports) of Faeroe Islands?
Your answer should be compact. 0.53. What is the difference between the highest and the second highest Cost of communications, computer etc. (% of service exports) of Finland?
Your answer should be compact. 1.91. What is the difference between the highest and the lowest Cost of communications, computer etc. (% of service exports) of Bosnia and Herzegovina?
Your answer should be compact. 19.59. What is the difference between the highest and the lowest Cost of communications, computer etc. (% of service exports) of Faeroe Islands?
Ensure brevity in your answer.  23.78. What is the difference between the highest and the lowest Cost of communications, computer etc. (% of service exports) of Finland?
Provide a short and direct response. 12.58. 